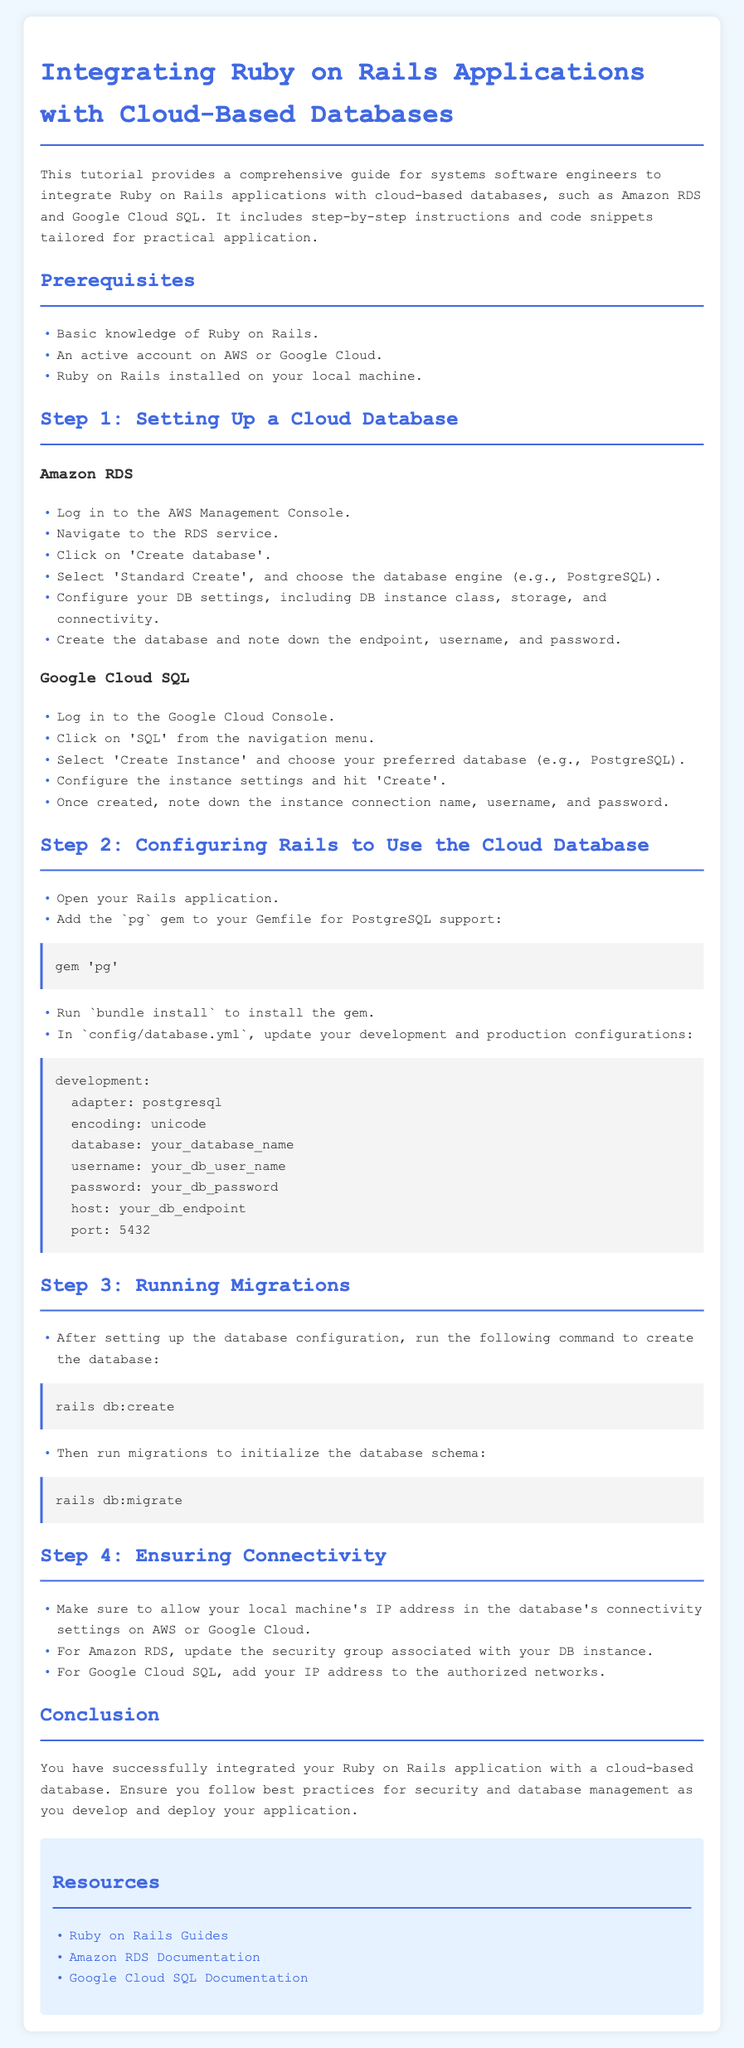What cloud database services are mentioned in the tutorial? The tutorial mentions Amazon RDS and Google Cloud SQL as cloud-based database services for integration with Ruby on Rails applications.
Answer: Amazon RDS, Google Cloud SQL What is the first step in the tutorial? The first step of the tutorial is about setting up a cloud database, specifically focusing on both Amazon RDS and Google Cloud SQL sections.
Answer: Setting Up a Cloud Database Which gem is recommended for PostgreSQL support? The tutorial suggests adding the 'pg' gem to the Gemfile for PostgreSQL support in the Rails application.
Answer: pg What command is used to create the database? The command to create the database in the context of the tutorial is specified as 'rails db:create'.
Answer: rails db:create How should the local machine's IP address be handled? The document states that you need to allow your local machine's IP address in the database's connectivity settings on AWS or Google Cloud.
Answer: Allowed in connectivity settings What is provided in the resources section? The resources include links to the Ruby on Rails Guides, Amazon RDS Documentation, and Google Cloud SQL Documentation for further reading.
Answer: Links to guides and documentation What should be updated for Amazon RDS? It is indicated that you need to update the security group associated with your DB instance for Amazon RDS to allow connectivity.
Answer: Update the security group What is the main purpose of this tutorial? The main purpose of the tutorial is to provide a comprehensive guide for systems software engineers for integrating Ruby on Rails applications with cloud-based databases.
Answer: Comprehensive guide for integration 